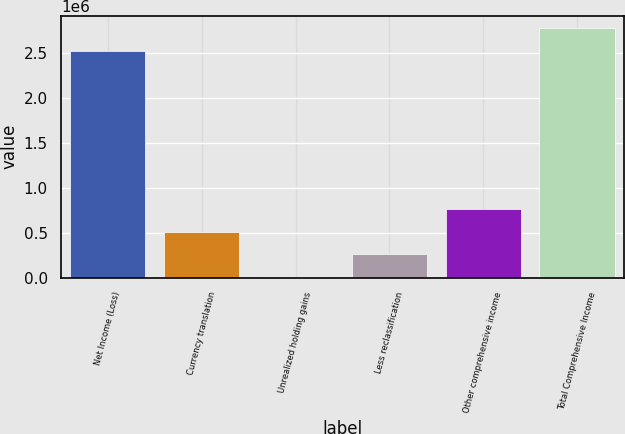Convert chart to OTSL. <chart><loc_0><loc_0><loc_500><loc_500><bar_chart><fcel>Net Income (Loss)<fcel>Currency translation<fcel>Unrealized holding gains<fcel>Less reclassification<fcel>Other comprehensive income<fcel>Total Comprehensive Income<nl><fcel>2.51776e+06<fcel>513729<fcel>3614<fcel>258672<fcel>768787<fcel>2.77282e+06<nl></chart> 